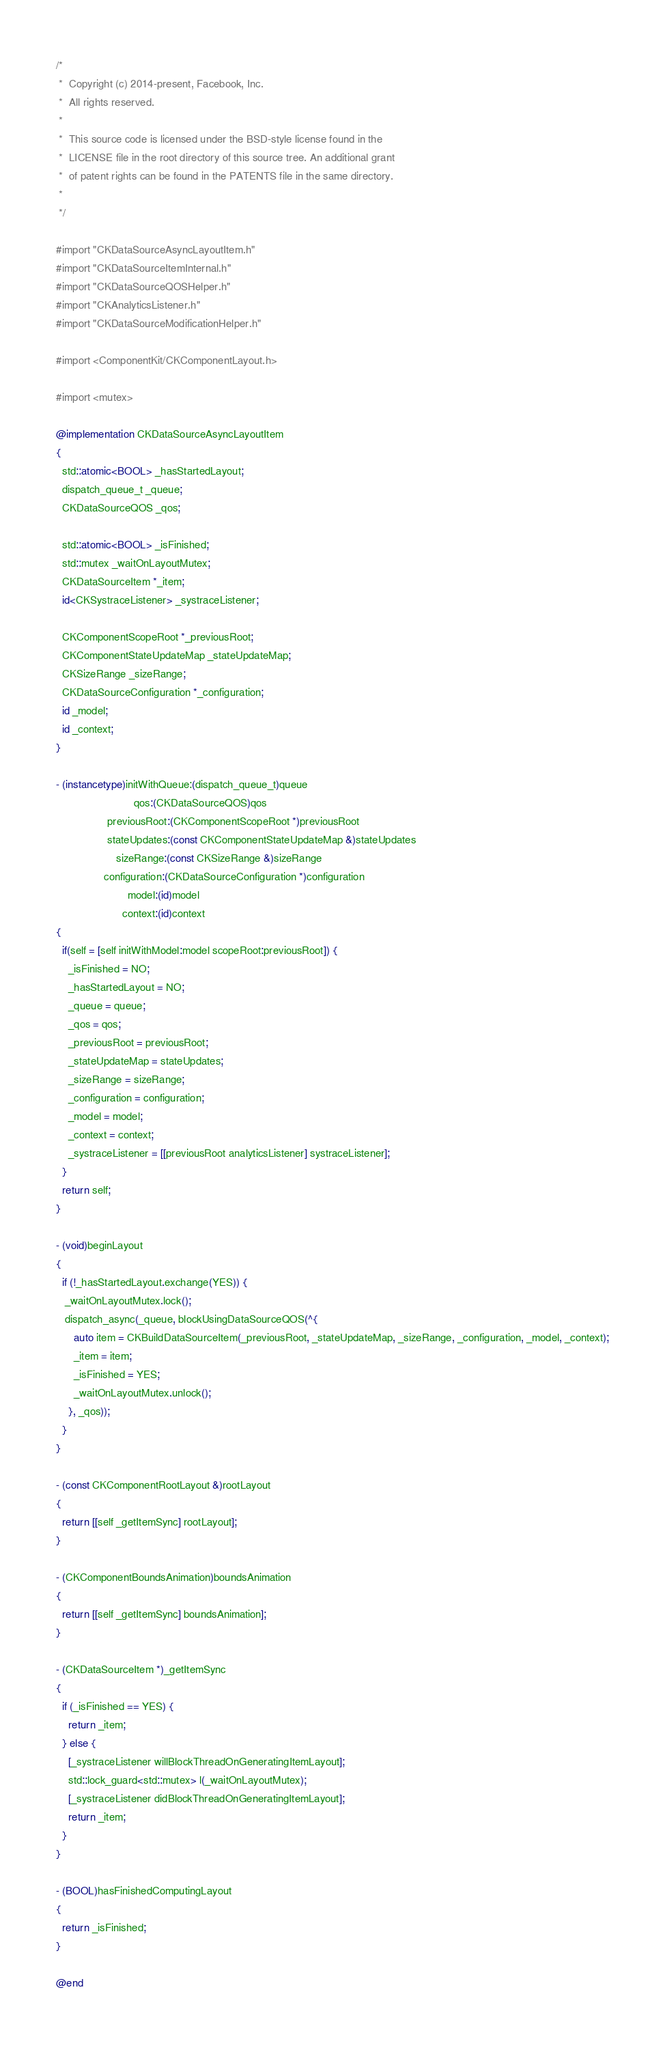<code> <loc_0><loc_0><loc_500><loc_500><_ObjectiveC_>/*
 *  Copyright (c) 2014-present, Facebook, Inc.
 *  All rights reserved.
 *
 *  This source code is licensed under the BSD-style license found in the
 *  LICENSE file in the root directory of this source tree. An additional grant
 *  of patent rights can be found in the PATENTS file in the same directory.
 *
 */

#import "CKDataSourceAsyncLayoutItem.h"
#import "CKDataSourceItemInternal.h"
#import "CKDataSourceQOSHelper.h"
#import "CKAnalyticsListener.h"
#import "CKDataSourceModificationHelper.h"

#import <ComponentKit/CKComponentLayout.h>

#import <mutex>

@implementation CKDataSourceAsyncLayoutItem
{
  std::atomic<BOOL> _hasStartedLayout;
  dispatch_queue_t _queue;
  CKDataSourceQOS _qos;

  std::atomic<BOOL> _isFinished;
  std::mutex _waitOnLayoutMutex;
  CKDataSourceItem *_item;
  id<CKSystraceListener> _systraceListener;

  CKComponentScopeRoot *_previousRoot;
  CKComponentStateUpdateMap _stateUpdateMap;
  CKSizeRange _sizeRange;
  CKDataSourceConfiguration *_configuration;
  id _model;
  id _context;
}

- (instancetype)initWithQueue:(dispatch_queue_t)queue
                          qos:(CKDataSourceQOS)qos
                 previousRoot:(CKComponentScopeRoot *)previousRoot
                 stateUpdates:(const CKComponentStateUpdateMap &)stateUpdates
                    sizeRange:(const CKSizeRange &)sizeRange
                configuration:(CKDataSourceConfiguration *)configuration
                        model:(id)model
                      context:(id)context
{
  if(self = [self initWithModel:model scopeRoot:previousRoot]) {
    _isFinished = NO;
    _hasStartedLayout = NO;
    _queue = queue;
    _qos = qos;
    _previousRoot = previousRoot;
    _stateUpdateMap = stateUpdates;
    _sizeRange = sizeRange;
    _configuration = configuration;
    _model = model;
    _context = context;
    _systraceListener = [[previousRoot analyticsListener] systraceListener];
  }
  return self;
}

- (void)beginLayout
{
  if (!_hasStartedLayout.exchange(YES)) {
   _waitOnLayoutMutex.lock();
   dispatch_async(_queue, blockUsingDataSourceQOS(^{
      auto item = CKBuildDataSourceItem(_previousRoot, _stateUpdateMap, _sizeRange, _configuration, _model, _context);
      _item = item;
      _isFinished = YES;
      _waitOnLayoutMutex.unlock();
    }, _qos));
  }
}

- (const CKComponentRootLayout &)rootLayout
{
  return [[self _getItemSync] rootLayout];
}

- (CKComponentBoundsAnimation)boundsAnimation
{
  return [[self _getItemSync] boundsAnimation];
}

- (CKDataSourceItem *)_getItemSync
{
  if (_isFinished == YES) {
    return _item;
  } else {
    [_systraceListener willBlockThreadOnGeneratingItemLayout];
    std::lock_guard<std::mutex> l(_waitOnLayoutMutex);
    [_systraceListener didBlockThreadOnGeneratingItemLayout];
    return _item;
  }
}

- (BOOL)hasFinishedComputingLayout
{
  return _isFinished;
}

@end
</code> 